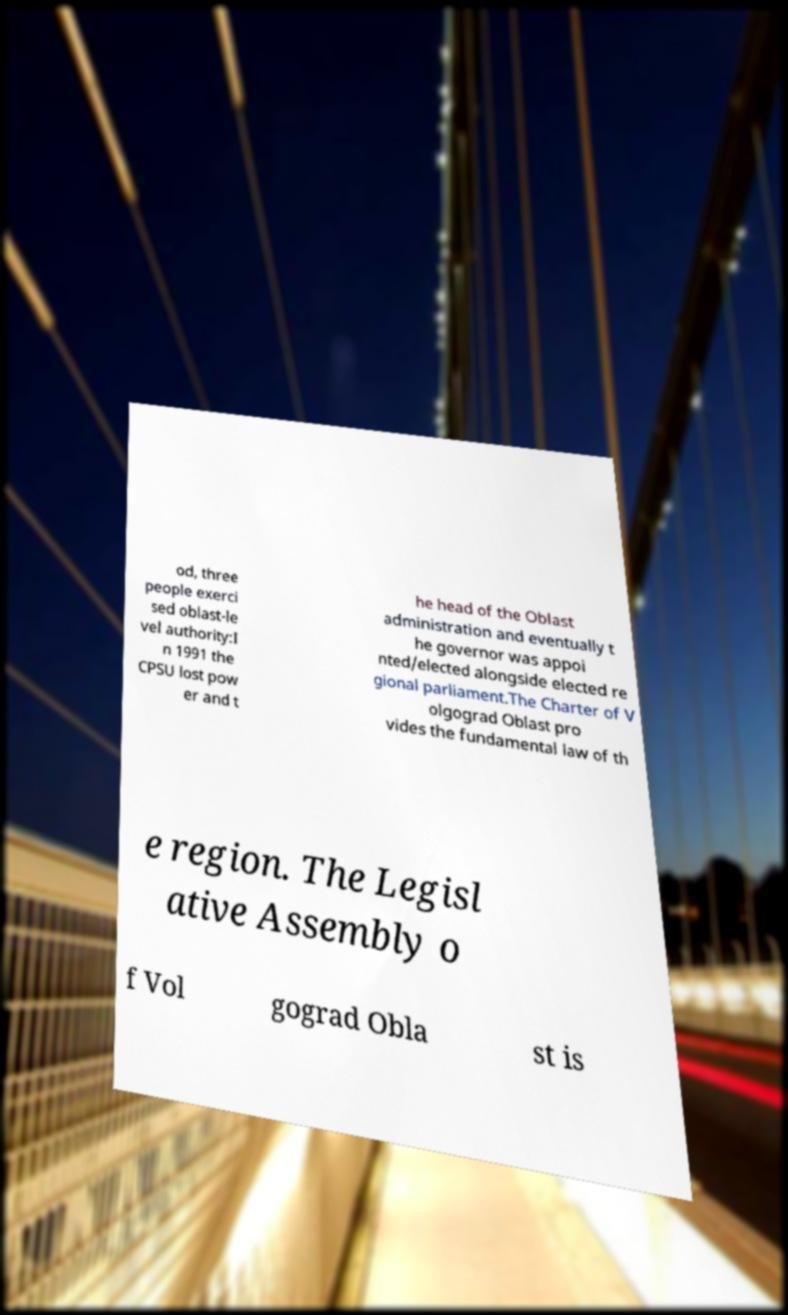Please identify and transcribe the text found in this image. od, three people exerci sed oblast-le vel authority:I n 1991 the CPSU lost pow er and t he head of the Oblast administration and eventually t he governor was appoi nted/elected alongside elected re gional parliament.The Charter of V olgograd Oblast pro vides the fundamental law of th e region. The Legisl ative Assembly o f Vol gograd Obla st is 